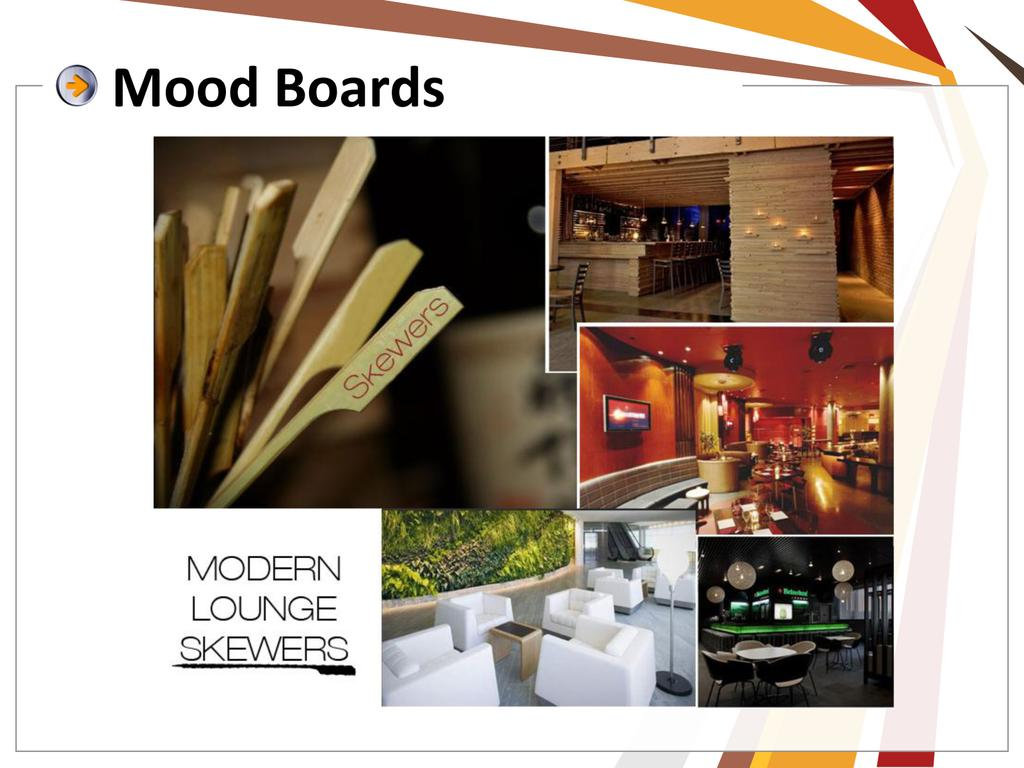What is the main subject of the poster in the image? The poster contains images of various objects, including sticks, a television, chairs, tables, walls, lights, and grass. Does the poster contain any text? Yes, the poster contains some text. Can you describe the images of objects on the poster? The poster contains images of sticks, a television, chairs, tables, walls, lights, and grass. What type of cap is being worn by the person in the image? There is no person present in the image, only a poster with various objects depicted. What is the reaction of the person to the vessel in the image? There is no person or vessel present in the image, only a poster with various objects depicted. 